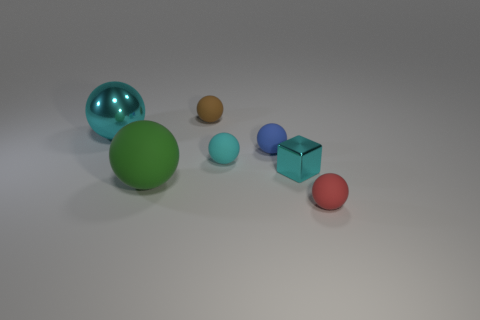Subtract all blue matte spheres. How many spheres are left? 5 Subtract all red balls. How many balls are left? 5 Add 3 brown matte objects. How many objects exist? 10 Subtract 4 balls. How many balls are left? 2 Subtract all purple cylinders. How many cyan spheres are left? 2 Subtract all balls. How many objects are left? 1 Subtract all yellow spheres. Subtract all yellow cubes. How many spheres are left? 6 Subtract all tiny metal blocks. Subtract all cyan rubber cubes. How many objects are left? 6 Add 5 blue matte balls. How many blue matte balls are left? 6 Add 1 brown matte things. How many brown matte things exist? 2 